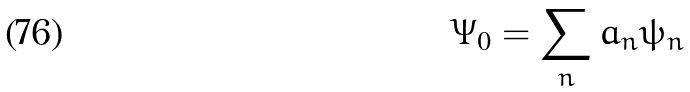<formula> <loc_0><loc_0><loc_500><loc_500>\Psi _ { 0 } = \sum _ { n } a _ { n } \psi _ { n }</formula> 